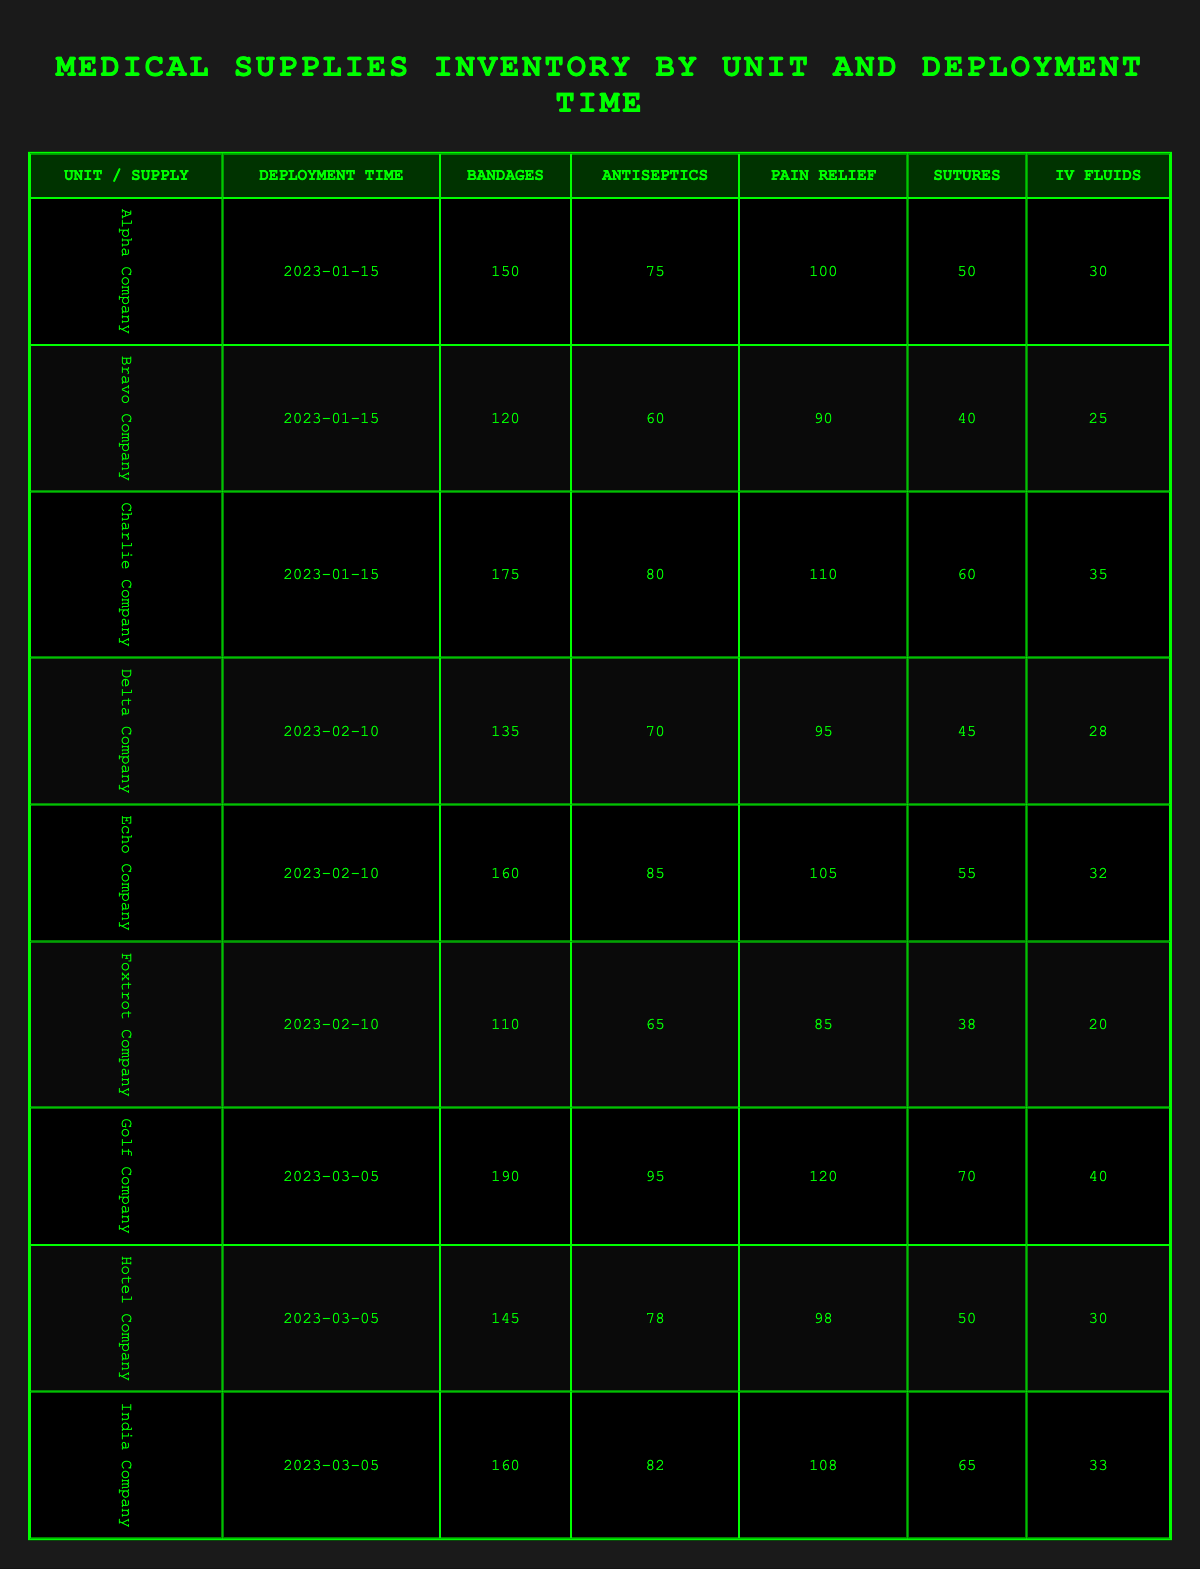What is the total number of bandages available across all companies for the deployment on 2023-01-15? The total number of bandages for the deployment on 2023-01-15 can be calculated by summing the values from the respective companies: Alpha Company (150) + Bravo Company (120) + Charlie Company (175) = 445.
Answer: 445 Which company has the highest supply of IV fluids during its deployment? By examining the IV fluids column across all companies, Golf Company has the highest supply at 40 units.
Answer: Golf Company Are there any companies with fewer than 80 antiseptics for the deployment on 2023-02-10? Checking the antiseptics column for the deployment on 2023-02-10: Delta Company (70) and Foxtrot Company (65) both have fewer than 80.
Answer: Yes What is the average amount of pain relief supplies across all companies for the deployment on 2023-03-05? The pain relief supplies for the companies on 2023-03-05 are: Golf Company (120), Hotel Company (98), and India Company (108). The total is 120 + 98 + 108 = 326. To find the average, divide by the number of companies: 326 / 3 = approximately 108.67.
Answer: 108.67 Is Charlie Company equipped with more sutures than Alpha Company? Charlie Company has 60 sutures while Alpha Company has 50. Since 60 is greater than 50, the statement is true.
Answer: Yes What is the difference in the number of bandages between the unit with the maximum and minimum for the deployment on 2023-01-15? The maximum number of bandages for 2023-01-15 is from Charlie Company at 175, and the minimum is from Bravo Company at 120. The difference is 175 - 120 = 55.
Answer: 55 How many total antiseptics are provided by the three units with the highest total antiseptics deployed? The units and their antiseptic supplies for the different deployments are: Charlie Company (80), Echo Company (85), and Golf Company (95). The total is 80 + 85 + 95 = 260.
Answer: 260 Did any company deployed on the later dates have more bandages than the maximum on the earlier date of 2023-01-15? The maximum number of bandages on 2023-01-15 is 175 (Charlie Company), and for the later dates: Echo Company (160) and India Company (160) both have fewer. Thus, no company deployed later exceeded this maximum.
Answer: No 